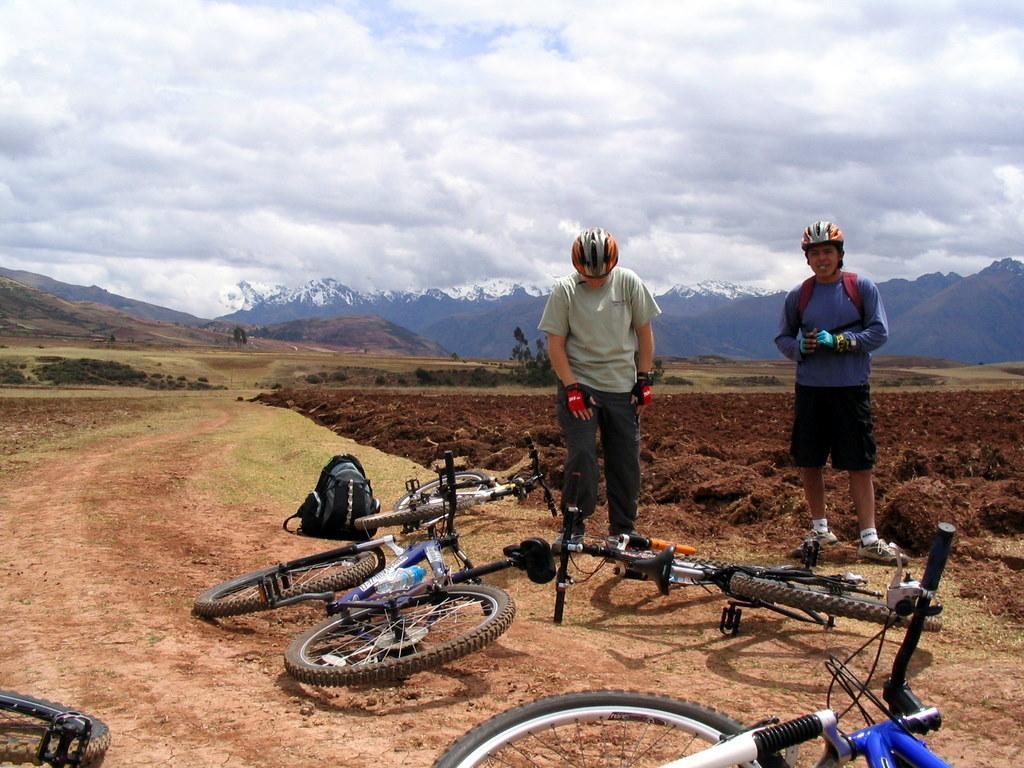How many people are in the image? There are two people in the image. What are the people doing in the image? The people are on bicycles. Where are the bicycles located in the image? The bicycles are on the ground. What can be seen in the background of the image? There are trees, mountains, and the sky visible in the background of the image. What type of toys can be seen scattered around the people in the image? There are no toys present in the image. How many oranges are being held by the people in the image? There are no oranges visible in the image. 